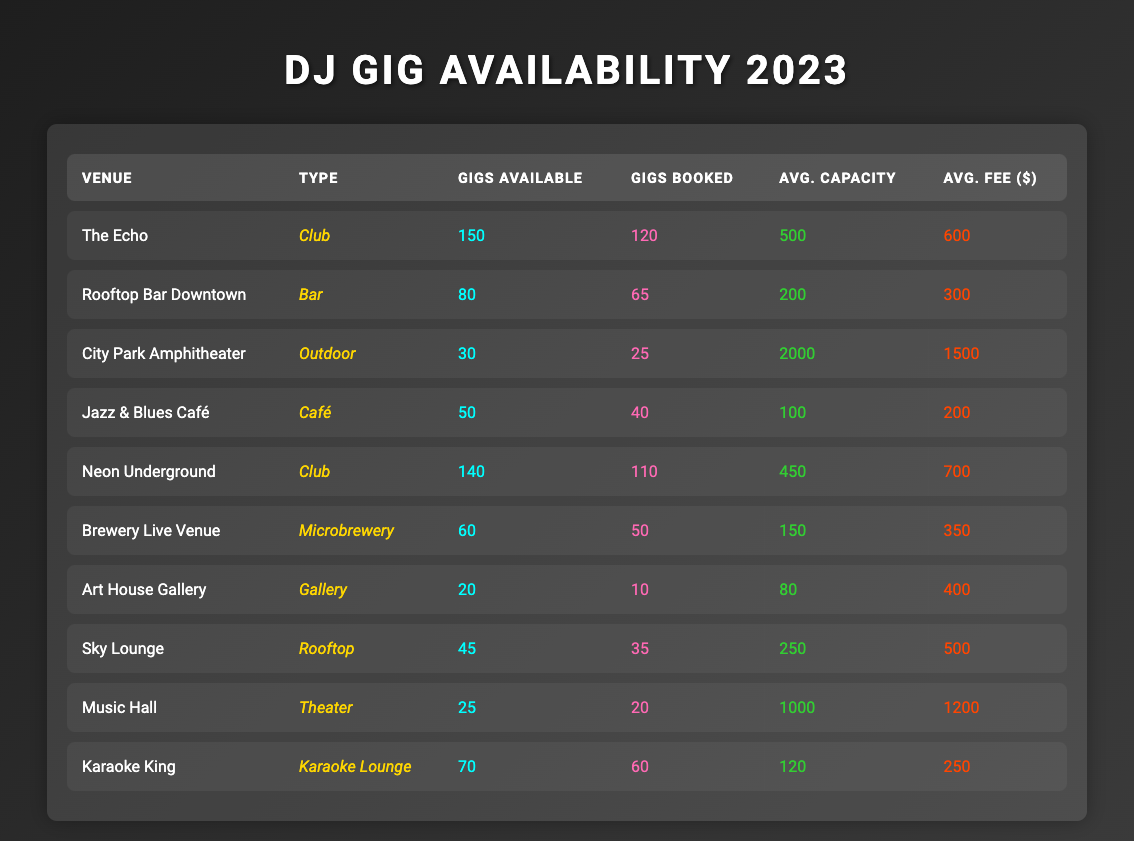What is the average fee for gigs at club venues? The clubs listed are "The Echo" with an average fee of $600 and "Neon Underground" with an average fee of $700. To find the average fee, you sum these values (600 + 700) = 1300, and then divide by the number of clubs (2), so the average fee is 1300/2 = 650.
Answer: 650 Which venue type has the highest number of gigs available? The venue type with the highest gigs available is "Club," with "The Echo" offering 150 gigs and "Neon Underground" offering 140 gigs, summing to 290. Compared to other venue types, Club has the most.
Answer: Club How many gigs were booked at the Rooftop Bar Downtown? The table indicates "Rooftop Bar Downtown" booked 65 gigs, as listed under the "Gigs Booked" column.
Answer: 65 Is City Park Amphitheater operating at full capacity in terms of gigs booked? City Park Amphitheater has 30 gigs available, and 25 have been booked. This indicates they are not operating at full capacity since 30 - 25 = 5 gigs are still available.
Answer: No What is the total number of gigs booked at all venues? Adding up the gigs booked from each venue: 120 + 65 + 25 + 40 + 110 + 50 + 10 + 35 + 20 + 60 = 575. Thus, the total number of gigs booked across all venues is 575.
Answer: 575 Are there more total gigs available at Clubs than in all other venue types combined? There are 150 gigs available at "The Echo" and 140 at "Neon Underground," making a total of 290 gigs available at Clubs. For other venues, we sum: 80 (Bar) + 30 (Outdoor) + 50 (Café) + 60 (Microbrewery) + 20 (Gallery) + 45 (Rooftop) + 25 (Theater) + 70 (Karaoke Lounge) = 410. Since 290 < 410, there are not more total gigs available at Clubs.
Answer: No What venue type has the smallest average capacity? The venues' average capacities are: Club (475), Bar (200), Outdoor (2000), Café (100), Microbrewery (150), Gallery (80), Rooftop (250), Theater (1000), Karaoke Lounge (120). The Gallery has the smallest average capacity of 80.
Answer: Gallery What percentage of gigs are booked at the Neon Underground venue? Neon Underground has 140 gigs available and 110 booked, so the percentage booked is calculated as (110/140) * 100 = 78.57%. Therefore, 78.57% of gigs are booked at Neon Underground.
Answer: 78.57% How many more gigs available does The Echo have compared to the average number of gigs available across all venues? The Echo has 150 gigs available. Sum of gigs available across all venues is 150 + 80 + 30 + 50 + 140 + 60 + 20 + 45 + 25 + 70 = 650. The average number gigs available is 650/10 = 65. So, 150 - 65 = 85 more gigs available at The Echo.
Answer: 85 Are there any venues with more gigs available than gigs booked? Yes, "The Echo" has 150 gigs available and 120 booked; "Neon Underground" has 140 gigs available and 110 booked; "Brewery Live Venue" has 60 gigs available and 50 booked, and "Karaoke King" has 70 available and 60 booked. All these venues have more gigs available than booked.
Answer: Yes 